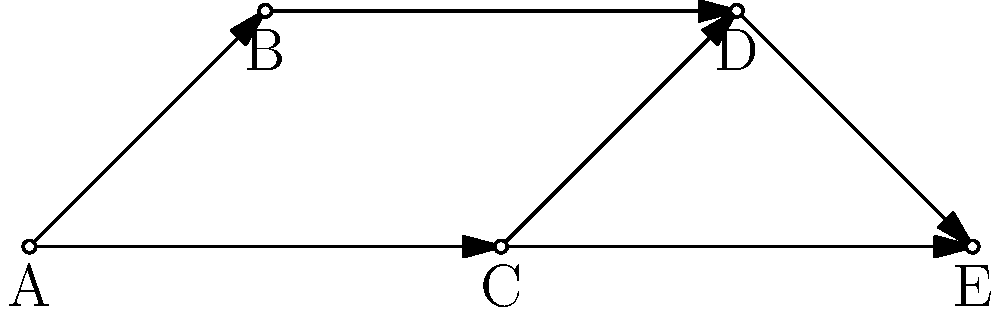Given the directed graph representing access control paths in your manufacturing company, where each node represents a user group and each edge represents access granted from one group to another, what is the minimum number of direct access grants needed to ensure that group E can access resources from all other groups (A, B, C, and D)? To solve this problem, we need to analyze the graph and find the minimum number of edges (access grants) that need to be added to ensure group E has access to all other groups. Let's approach this step-by-step:

1. Current state:
   - E already has direct access from C and D
   - E doesn't have direct access from A and B

2. Analyze existing paths:
   - A → B → D → E
   - A → C → E
   - B → D → E

3. Identify missing direct connections:
   - A → E
   - B → E

4. Determine the minimum number of new connections:
   - We only need to add A → E
   - This is because:
     a) A → E covers the direct connection from A
     b) B can still reach E through the existing path B → D → E

5. Conclusion:
   Only one new direct access grant (A → E) is needed to ensure E can access resources from all other groups.

This solution optimizes the access control structure by minimizing the number of direct grants while ensuring full accessibility for group E.
Answer: 1 